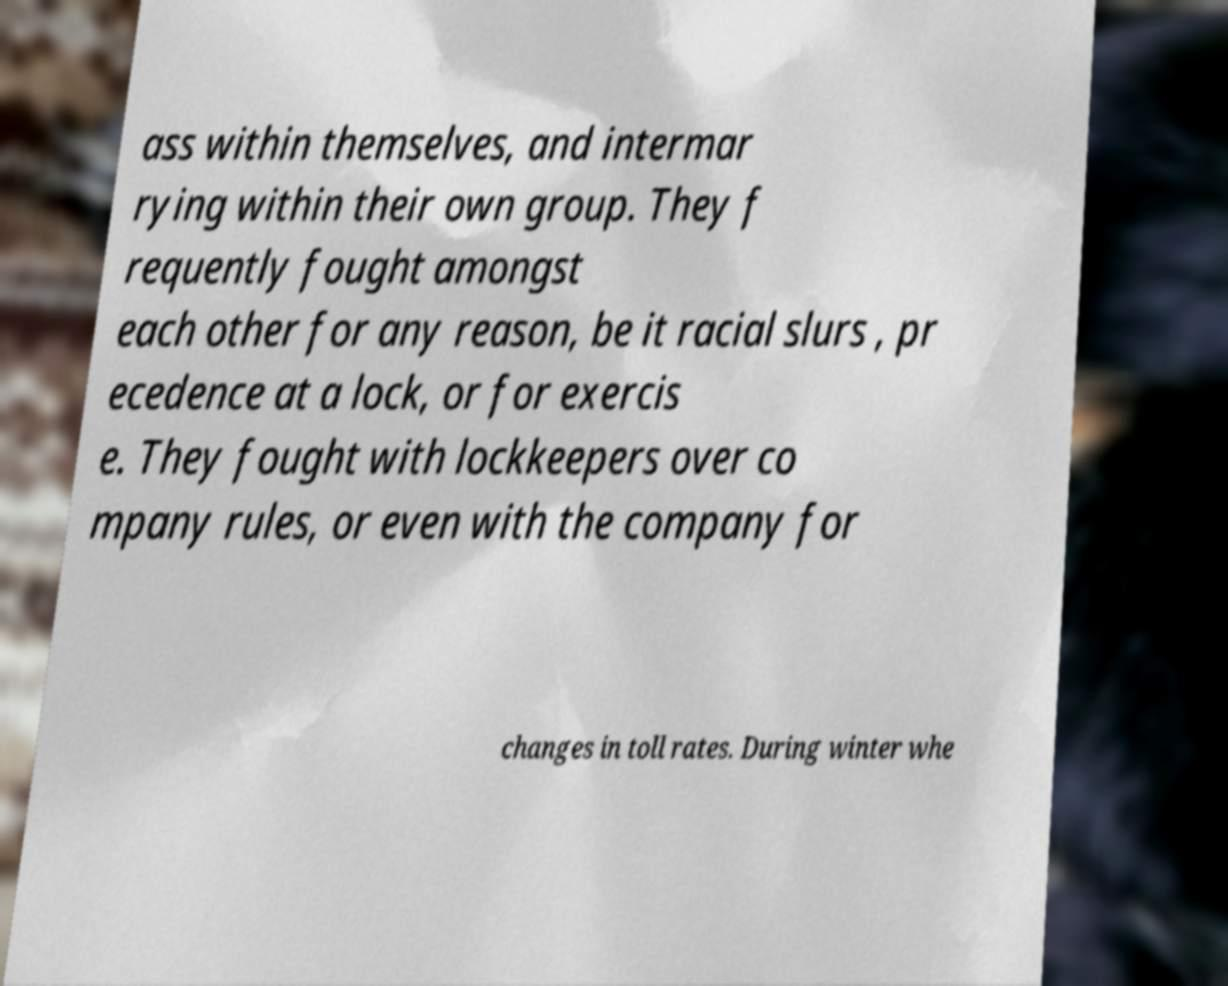Can you accurately transcribe the text from the provided image for me? ass within themselves, and intermar rying within their own group. They f requently fought amongst each other for any reason, be it racial slurs , pr ecedence at a lock, or for exercis e. They fought with lockkeepers over co mpany rules, or even with the company for changes in toll rates. During winter whe 